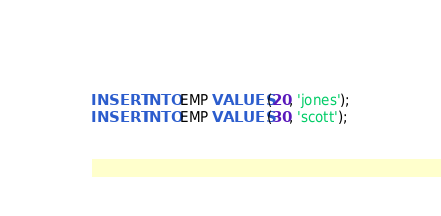Convert code to text. <code><loc_0><loc_0><loc_500><loc_500><_SQL_>INSERT INTO EMP VALUES (20, 'jones');
INSERT INTO EMP VALUES (30, 'scott');

</code> 